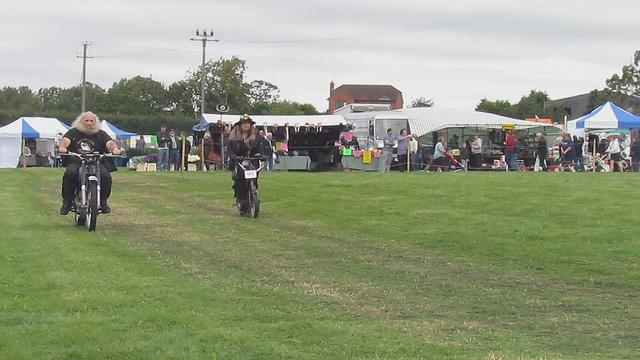What type food is more likely served here? Please explain your reasoning. hot dog. Hot dogs would be a good food to serve at the event. 